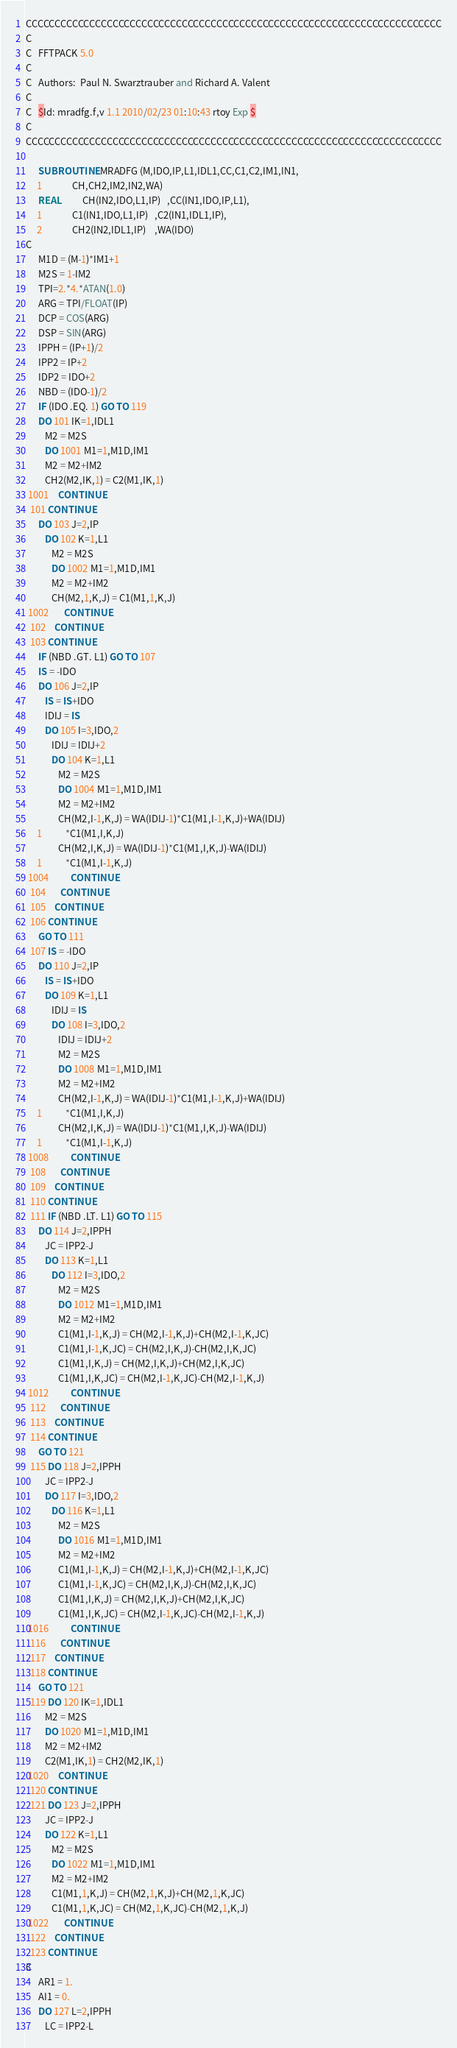Convert code to text. <code><loc_0><loc_0><loc_500><loc_500><_FORTRAN_>CCCCCCCCCCCCCCCCCCCCCCCCCCCCCCCCCCCCCCCCCCCCCCCCCCCCCCCCCCCCCCCCCCCCCCCC
C
C   FFTPACK 5.0 
C
C   Authors:  Paul N. Swarztrauber and Richard A. Valent
C
C   $Id: mradfg.f,v 1.1 2010/02/23 01:10:43 rtoy Exp $
C
CCCCCCCCCCCCCCCCCCCCCCCCCCCCCCCCCCCCCCCCCCCCCCCCCCCCCCCCCCCCCCCCCCCCCCCC

      SUBROUTINE MRADFG (M,IDO,IP,L1,IDL1,CC,C1,C2,IM1,IN1,
     1              CH,CH2,IM2,IN2,WA)
      REAL          CH(IN2,IDO,L1,IP)   ,CC(IN1,IDO,IP,L1),
     1              C1(IN1,IDO,L1,IP)   ,C2(IN1,IDL1,IP),
     2              CH2(IN2,IDL1,IP)    ,WA(IDO)
C
      M1D = (M-1)*IM1+1
      M2S = 1-IM2
      TPI=2.*4.*ATAN(1.0)
      ARG = TPI/FLOAT(IP)
      DCP = COS(ARG)
      DSP = SIN(ARG)
      IPPH = (IP+1)/2
      IPP2 = IP+2
      IDP2 = IDO+2
      NBD = (IDO-1)/2
      IF (IDO .EQ. 1) GO TO 119
      DO 101 IK=1,IDL1
         M2 = M2S
         DO 1001 M1=1,M1D,IM1
         M2 = M2+IM2
         CH2(M2,IK,1) = C2(M1,IK,1)
 1001    CONTINUE
  101 CONTINUE
      DO 103 J=2,IP
         DO 102 K=1,L1
            M2 = M2S
            DO 1002 M1=1,M1D,IM1
            M2 = M2+IM2
            CH(M2,1,K,J) = C1(M1,1,K,J)
 1002       CONTINUE
  102    CONTINUE
  103 CONTINUE
      IF (NBD .GT. L1) GO TO 107
      IS = -IDO
      DO 106 J=2,IP
         IS = IS+IDO
         IDIJ = IS
         DO 105 I=3,IDO,2
            IDIJ = IDIJ+2
            DO 104 K=1,L1
               M2 = M2S
               DO 1004 M1=1,M1D,IM1
               M2 = M2+IM2
               CH(M2,I-1,K,J) = WA(IDIJ-1)*C1(M1,I-1,K,J)+WA(IDIJ)
     1           *C1(M1,I,K,J)
               CH(M2,I,K,J) = WA(IDIJ-1)*C1(M1,I,K,J)-WA(IDIJ)
     1           *C1(M1,I-1,K,J)
 1004          CONTINUE
  104       CONTINUE
  105    CONTINUE
  106 CONTINUE
      GO TO 111
  107 IS = -IDO
      DO 110 J=2,IP
         IS = IS+IDO
         DO 109 K=1,L1
            IDIJ = IS
            DO 108 I=3,IDO,2
               IDIJ = IDIJ+2
               M2 = M2S
               DO 1008 M1=1,M1D,IM1
               M2 = M2+IM2
               CH(M2,I-1,K,J) = WA(IDIJ-1)*C1(M1,I-1,K,J)+WA(IDIJ)
     1           *C1(M1,I,K,J)
               CH(M2,I,K,J) = WA(IDIJ-1)*C1(M1,I,K,J)-WA(IDIJ)
     1           *C1(M1,I-1,K,J)
 1008          CONTINUE
  108       CONTINUE
  109    CONTINUE
  110 CONTINUE
  111 IF (NBD .LT. L1) GO TO 115
      DO 114 J=2,IPPH
         JC = IPP2-J
         DO 113 K=1,L1
            DO 112 I=3,IDO,2
               M2 = M2S
               DO 1012 M1=1,M1D,IM1
               M2 = M2+IM2
               C1(M1,I-1,K,J) = CH(M2,I-1,K,J)+CH(M2,I-1,K,JC)
               C1(M1,I-1,K,JC) = CH(M2,I,K,J)-CH(M2,I,K,JC)
               C1(M1,I,K,J) = CH(M2,I,K,J)+CH(M2,I,K,JC)
               C1(M1,I,K,JC) = CH(M2,I-1,K,JC)-CH(M2,I-1,K,J)
 1012          CONTINUE
  112       CONTINUE
  113    CONTINUE
  114 CONTINUE
      GO TO 121
  115 DO 118 J=2,IPPH
         JC = IPP2-J
         DO 117 I=3,IDO,2
            DO 116 K=1,L1
               M2 = M2S
               DO 1016 M1=1,M1D,IM1
               M2 = M2+IM2
               C1(M1,I-1,K,J) = CH(M2,I-1,K,J)+CH(M2,I-1,K,JC)
               C1(M1,I-1,K,JC) = CH(M2,I,K,J)-CH(M2,I,K,JC)
               C1(M1,I,K,J) = CH(M2,I,K,J)+CH(M2,I,K,JC)
               C1(M1,I,K,JC) = CH(M2,I-1,K,JC)-CH(M2,I-1,K,J)
 1016          CONTINUE
  116       CONTINUE
  117    CONTINUE
  118 CONTINUE
      GO TO 121
  119 DO 120 IK=1,IDL1
         M2 = M2S
         DO 1020 M1=1,M1D,IM1
         M2 = M2+IM2
         C2(M1,IK,1) = CH2(M2,IK,1)
 1020    CONTINUE
  120 CONTINUE
  121 DO 123 J=2,IPPH
         JC = IPP2-J
         DO 122 K=1,L1
            M2 = M2S
            DO 1022 M1=1,M1D,IM1
            M2 = M2+IM2
            C1(M1,1,K,J) = CH(M2,1,K,J)+CH(M2,1,K,JC)
            C1(M1,1,K,JC) = CH(M2,1,K,JC)-CH(M2,1,K,J)
 1022       CONTINUE
  122    CONTINUE
  123 CONTINUE
C
      AR1 = 1.
      AI1 = 0.
      DO 127 L=2,IPPH
         LC = IPP2-L</code> 